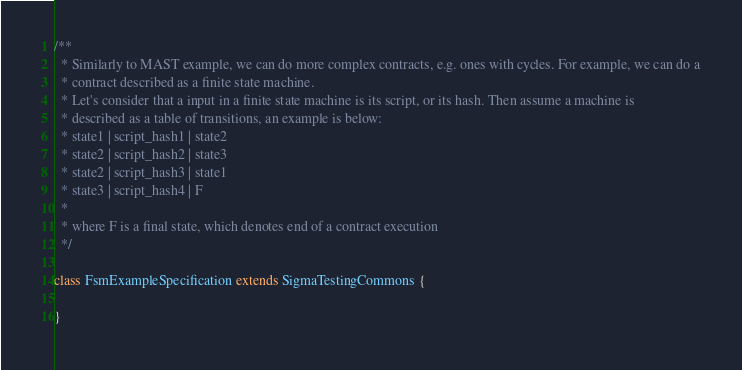<code> <loc_0><loc_0><loc_500><loc_500><_Scala_>/**
  * Similarly to MAST example, we can do more complex contracts, e.g. ones with cycles. For example, we can do a
  * contract described as a finite state machine.
  * Let's consider that a input in a finite state machine is its script, or its hash. Then assume a machine is
  * described as a table of transitions, an example is below:
  * state1 | script_hash1 | state2
  * state2 | script_hash2 | state3
  * state2 | script_hash3 | state1
  * state3 | script_hash4 | F
  *
  * where F is a final state, which denotes end of a contract execution
  */

class FsmExampleSpecification extends SigmaTestingCommons {

}
</code> 